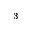Convert formula to latex. <formula><loc_0><loc_0><loc_500><loc_500>^ { 3 }</formula> 